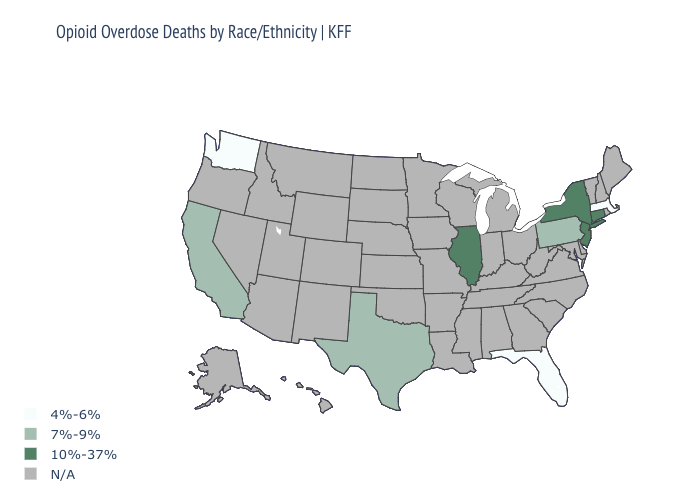Does the map have missing data?
Quick response, please. Yes. What is the value of North Dakota?
Concise answer only. N/A. Does the map have missing data?
Concise answer only. Yes. Is the legend a continuous bar?
Short answer required. No. Which states have the lowest value in the USA?
Quick response, please. Florida, Massachusetts, Washington. Name the states that have a value in the range N/A?
Short answer required. Alabama, Alaska, Arizona, Arkansas, Colorado, Delaware, Georgia, Hawaii, Idaho, Indiana, Iowa, Kansas, Kentucky, Louisiana, Maine, Maryland, Michigan, Minnesota, Mississippi, Missouri, Montana, Nebraska, Nevada, New Hampshire, New Mexico, North Carolina, North Dakota, Ohio, Oklahoma, Oregon, Rhode Island, South Carolina, South Dakota, Tennessee, Utah, Vermont, Virginia, West Virginia, Wisconsin, Wyoming. Name the states that have a value in the range N/A?
Be succinct. Alabama, Alaska, Arizona, Arkansas, Colorado, Delaware, Georgia, Hawaii, Idaho, Indiana, Iowa, Kansas, Kentucky, Louisiana, Maine, Maryland, Michigan, Minnesota, Mississippi, Missouri, Montana, Nebraska, Nevada, New Hampshire, New Mexico, North Carolina, North Dakota, Ohio, Oklahoma, Oregon, Rhode Island, South Carolina, South Dakota, Tennessee, Utah, Vermont, Virginia, West Virginia, Wisconsin, Wyoming. Name the states that have a value in the range N/A?
Answer briefly. Alabama, Alaska, Arizona, Arkansas, Colorado, Delaware, Georgia, Hawaii, Idaho, Indiana, Iowa, Kansas, Kentucky, Louisiana, Maine, Maryland, Michigan, Minnesota, Mississippi, Missouri, Montana, Nebraska, Nevada, New Hampshire, New Mexico, North Carolina, North Dakota, Ohio, Oklahoma, Oregon, Rhode Island, South Carolina, South Dakota, Tennessee, Utah, Vermont, Virginia, West Virginia, Wisconsin, Wyoming. What is the value of Texas?
Keep it brief. 7%-9%. Name the states that have a value in the range 4%-6%?
Be succinct. Florida, Massachusetts, Washington. Is the legend a continuous bar?
Quick response, please. No. What is the value of Arizona?
Concise answer only. N/A. 